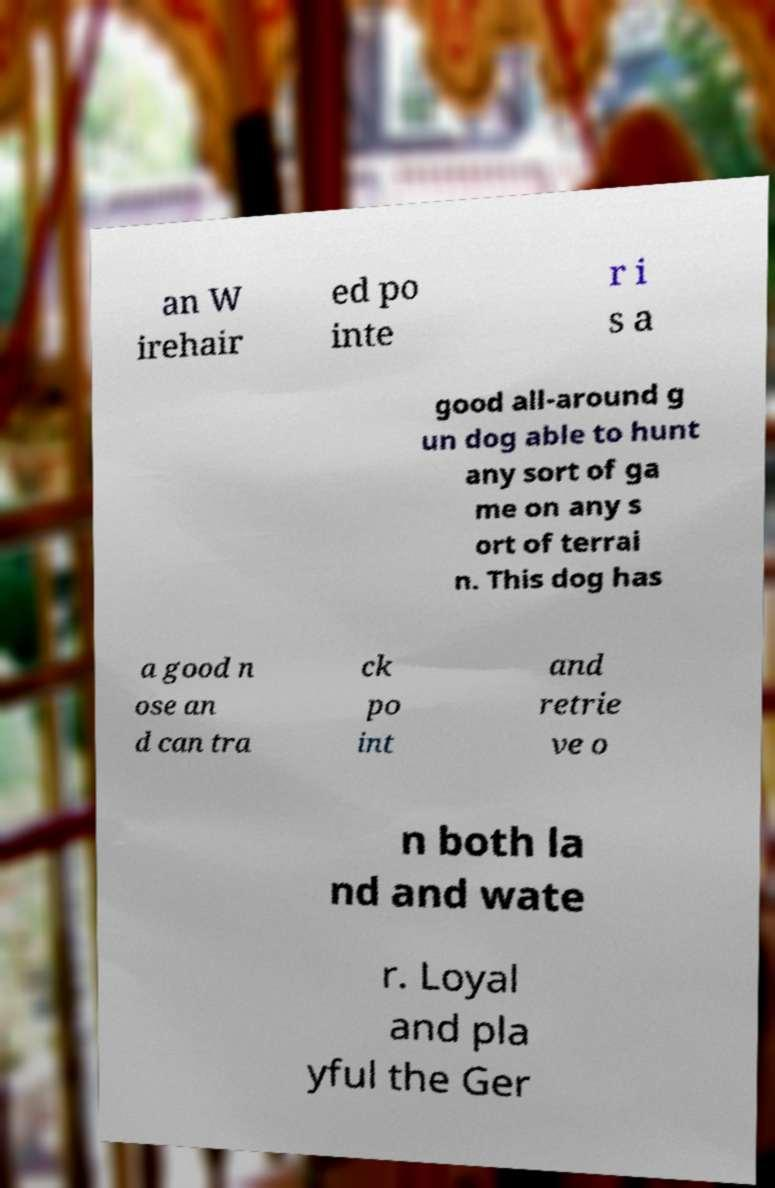Can you read and provide the text displayed in the image?This photo seems to have some interesting text. Can you extract and type it out for me? an W irehair ed po inte r i s a good all-around g un dog able to hunt any sort of ga me on any s ort of terrai n. This dog has a good n ose an d can tra ck po int and retrie ve o n both la nd and wate r. Loyal and pla yful the Ger 